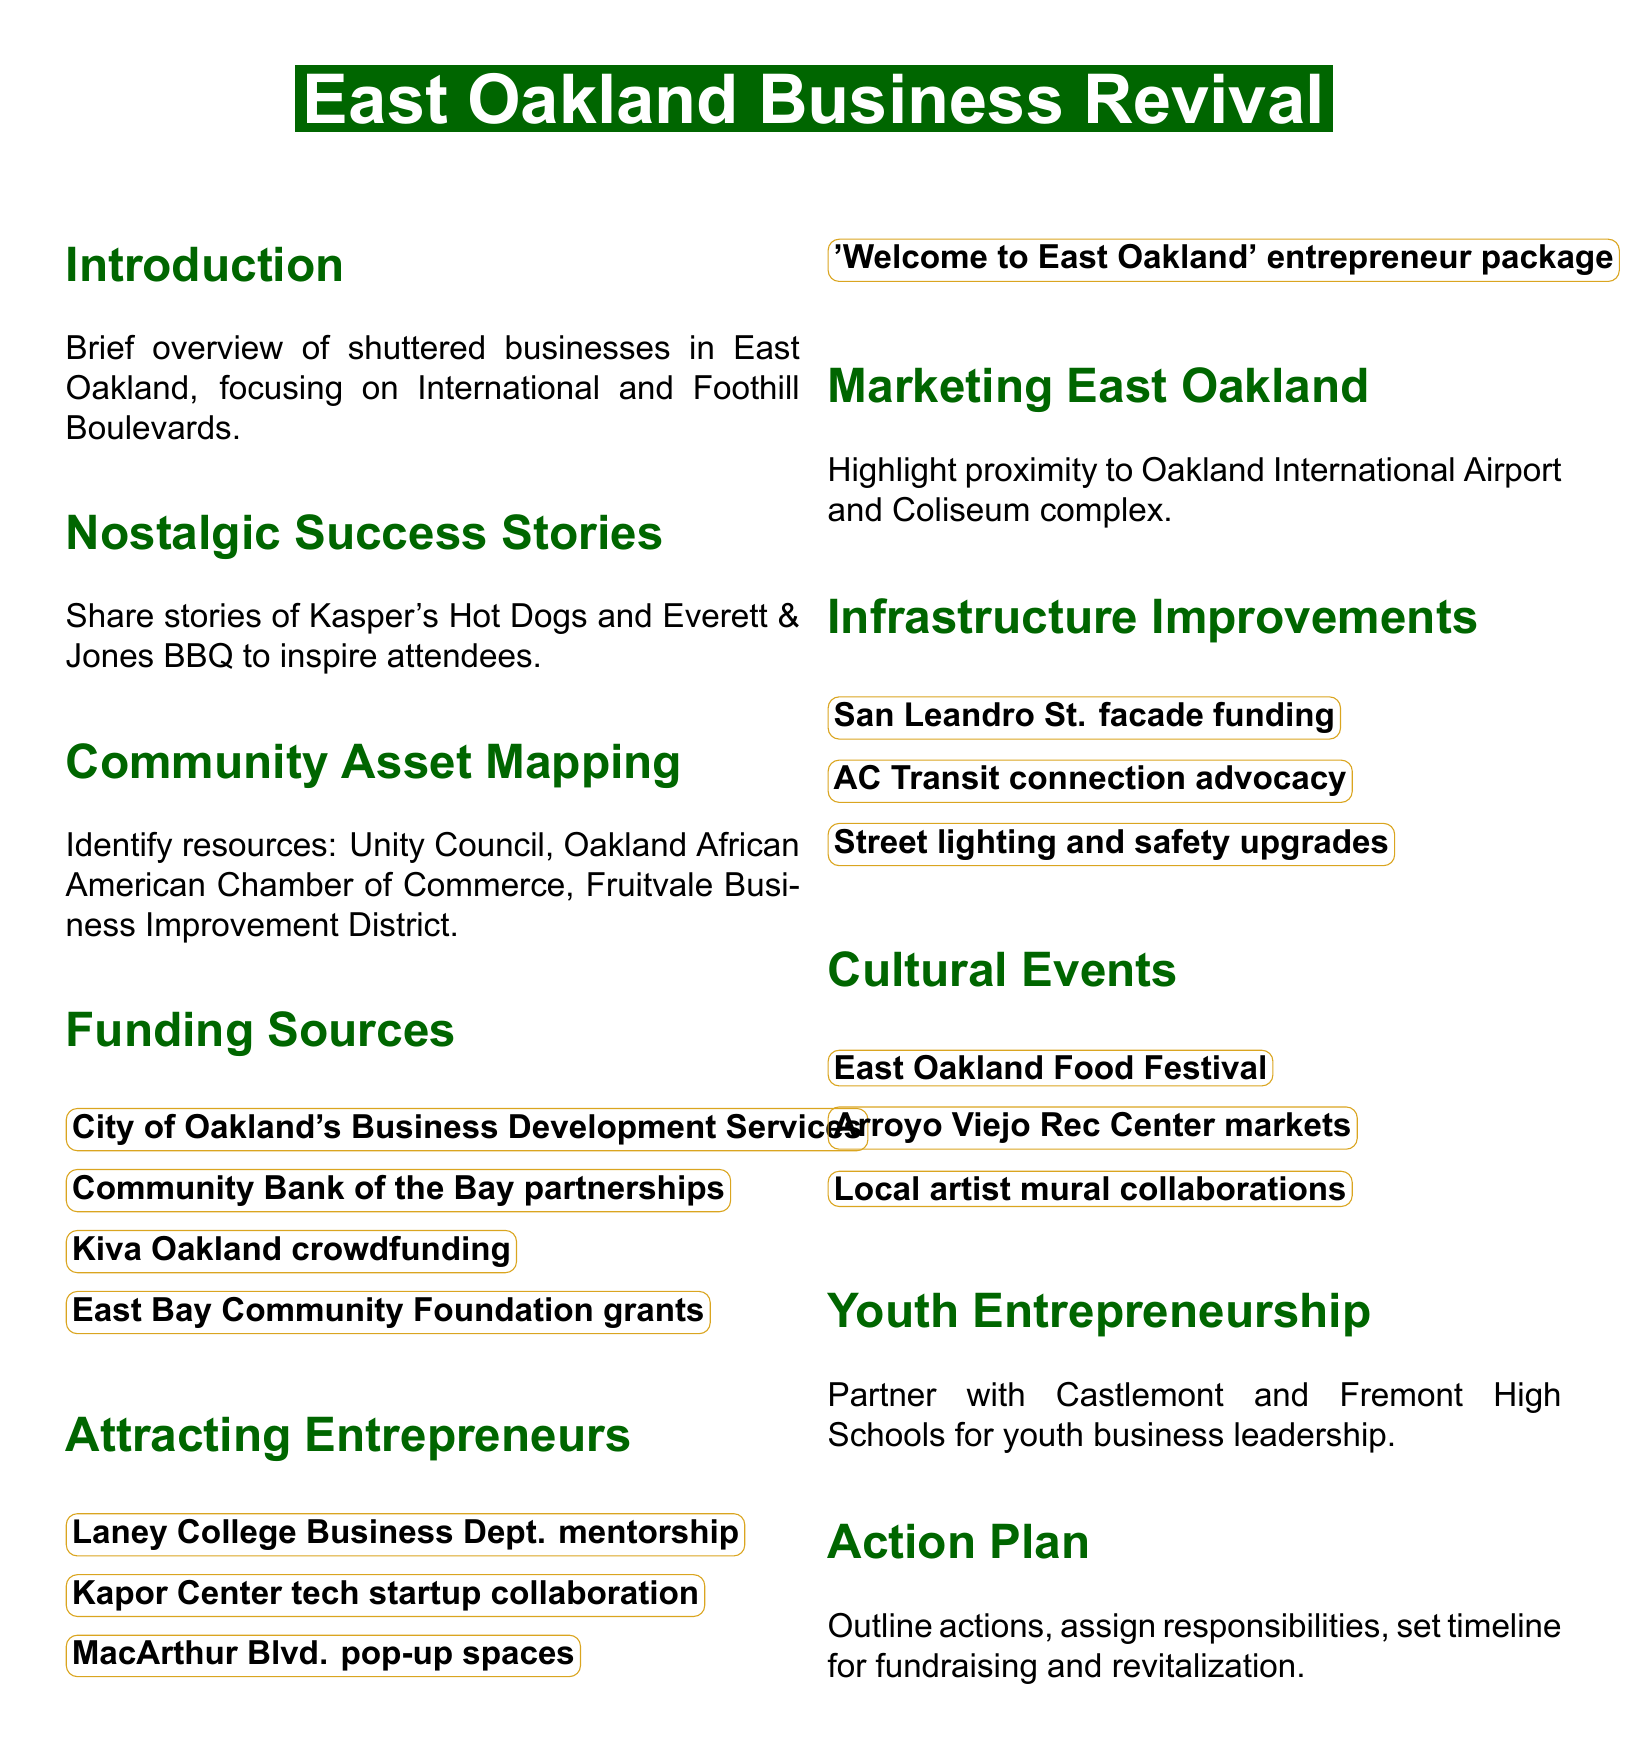What is the focus area mentioned in the introduction? The introduction specifically mentions shuttered businesses in East Oakland, focusing on International and Foothill Boulevards.
Answer: International and Foothill Boulevards Which two successful local businesses are highlighted in the document? The document shares stories of two successful local businesses from the past to inspire attendees.
Answer: Kasper's Hot Dogs and Everett & Jones BBQ What organization is suggested for partnerships in community asset mapping? The document lists potential partners during the community asset mapping discussion, one of which includes the Unity Council.
Answer: Unity Council Which funding source offers crowdfunding opportunities? The document discusses various funding sources, specifically mentioning one that specializes in crowdfunding.
Answer: Kiva Oakland What event is planned to boost foot traffic in East Oakland? The document lists various cultural events, one of which is focused on boosting foot traffic in the area.
Answer: East Oakland Food Festival What is one proposed improvement for infrastructure? The document includes infrastructure improvements, specifically one being sought for funding related to street aesthetics.
Answer: San Leandro Street facade funding Which local high schools are mentioned for youth entrepreneurship programs? The document identifies specific high schools that will partner to develop young business leaders.
Answer: Castlemont High School and Fremont High School What is the primary goal for the action plan section? The action plan section outlines specific goals regarding the implementation of strategies discussed earlier in the document.
Answer: Fundraising and revitalization strategies 